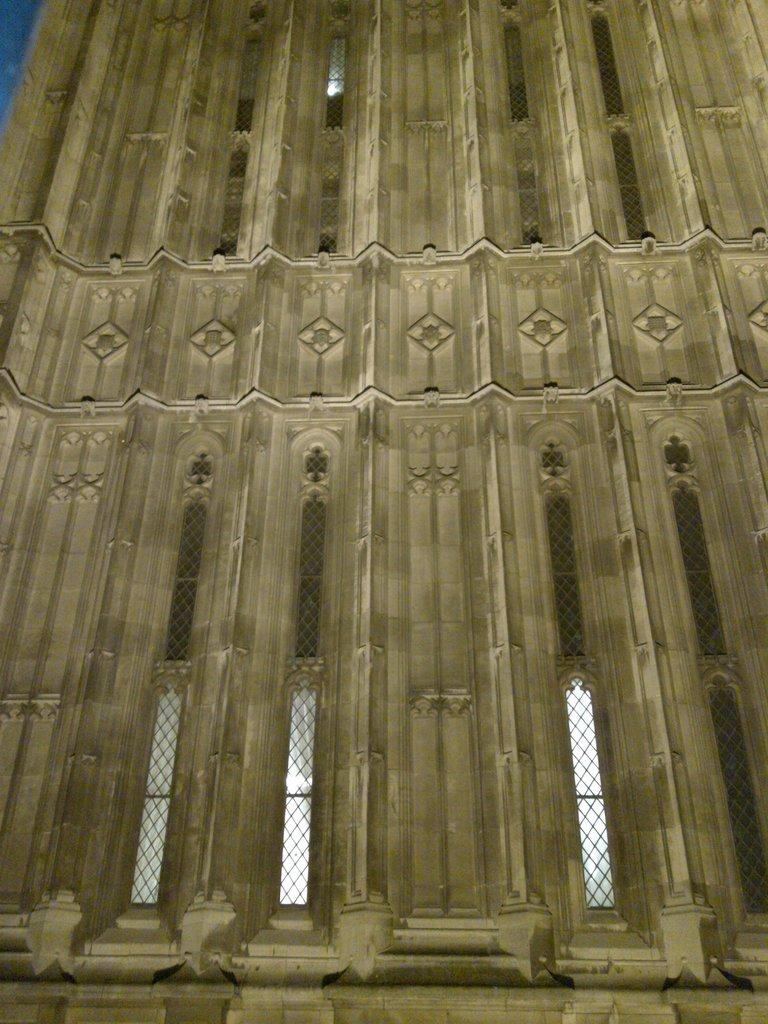What is the main subject of the image? The main subject of the image is a building wall. Are there any openings in the building wall? Yes, there are windows in the image. What can be seen in the background of the image? The sky is visible in the image. Can you determine the time of day the image was taken? The image may have been taken during the night, as there is no visible sunlight. What is the cause of the traffic jam on the journey depicted in the image? There is no journey or traffic jam depicted in the image; it features a building wall with windows and a visible sky. 